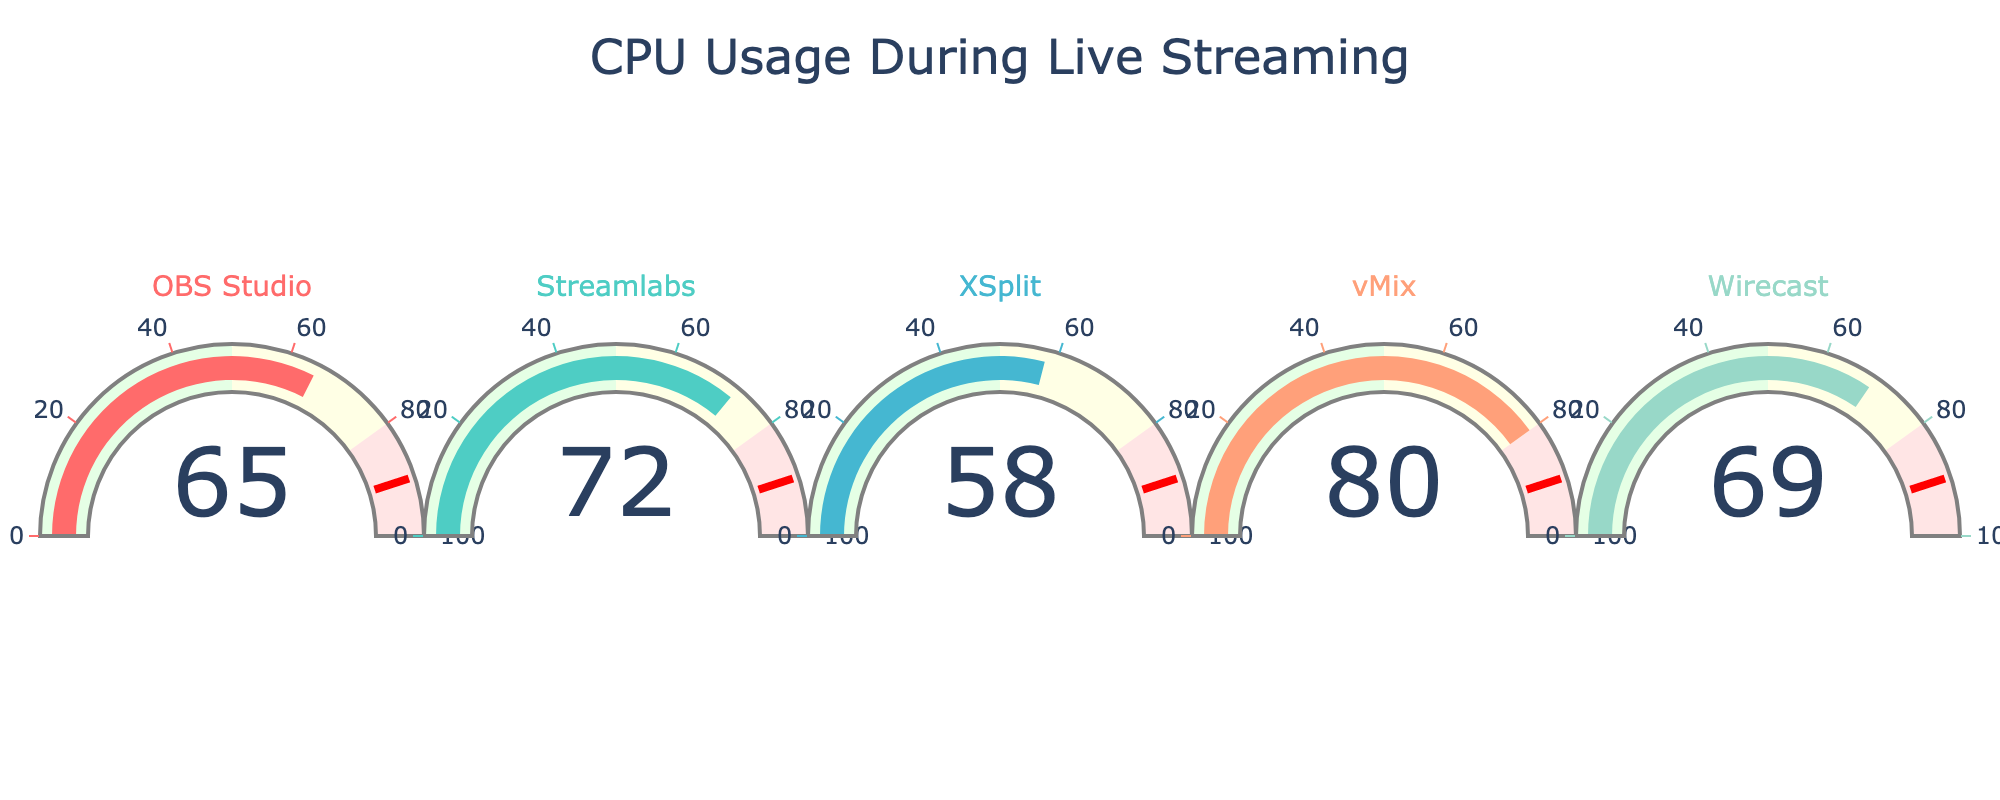What is the title of the gauge chart? The title is usually displayed prominently at the top center of the chart. In this chart, it is "CPU Usage During Live Streaming".
Answer: CPU Usage During Live Streaming How many CPUs are being monitored in this chart? By counting the number of gauges or checking the labels, we can see that there are 5 CPUs being monitored: OBS Studio, Streamlabs, XSplit, vMix, and Wirecast.
Answer: 5 Which CPU has the highest usage? By examining the gauge values, we find that vMix has the highest usage at 80%.
Answer: vMix Which CPU has the lowest usage? By examining the gauge values, we find that XSplit has the lowest usage at 58%.
Answer: XSplit What is the average usage of all the CPUs? To find the average, sum the usage percentages and divide by the number of CPUs. The total usage is 65 + 72 + 58 + 80 + 69 = 344. The average is 344/5 = 68.8%.
Answer: 68.8% What is the difference in CPU usage between OBS Studio and Wirecast? OBS Studio has a usage of 65% and Wirecast has 69%. The difference is 69% - 65% = 4%.
Answer: 4% Which CPU usage is closest to 70%? By examining the values, we see that Streamlabs has a usage of 72% and Wirecast has 69%. Wirecast is closest to 70%.
Answer: Wirecast Are any of the CPU usages above 75%? By inspecting the gauge values, we see that vMix (80%) is the only CPU with usage above 75%.
Answer: Yes, vMix What is the median usage value among the CPUs? To find the median, list the usage values in order: 58, 65, 69, 72, 80. The median value is the middle one, which is 69%.
Answer: 69% Which color represents OBS Studio? Each gauge has a distinct color. The color of OBS Studio's gauge is the first one in the provided color list: #FF6B6B, which is a light red color.
Answer: A light red color 